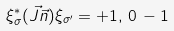<formula> <loc_0><loc_0><loc_500><loc_500>\xi _ { \sigma } ^ { * } ( \vec { J } \vec { n } ) \xi _ { \sigma ^ { \prime } } = + 1 , \, 0 \, - 1</formula> 